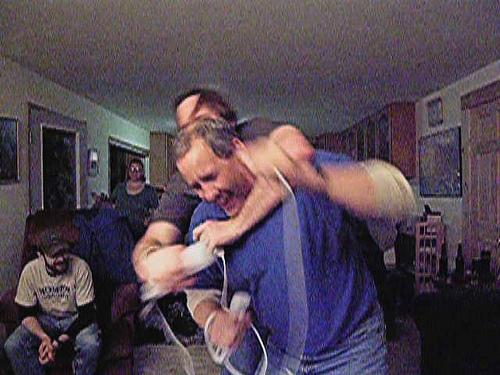What are the two men doing? Please explain your reasoning. wrestling. One man has is arms around another man and is tugging on him. 